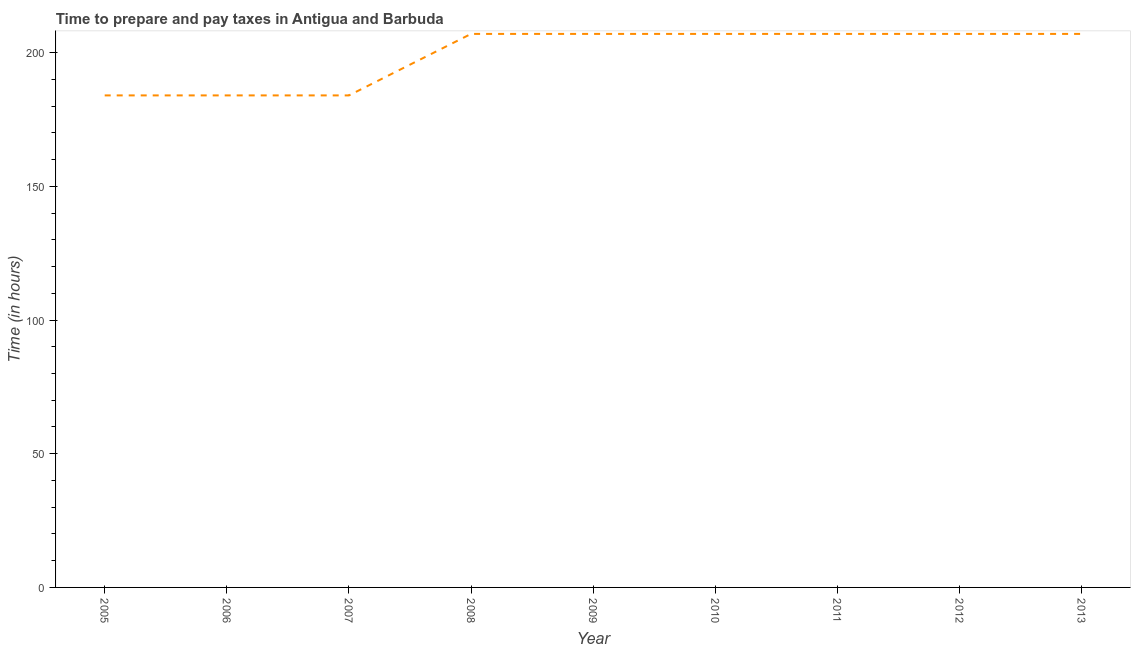What is the time to prepare and pay taxes in 2012?
Make the answer very short. 207. Across all years, what is the maximum time to prepare and pay taxes?
Keep it short and to the point. 207. Across all years, what is the minimum time to prepare and pay taxes?
Offer a very short reply. 184. In which year was the time to prepare and pay taxes maximum?
Ensure brevity in your answer.  2008. In which year was the time to prepare and pay taxes minimum?
Your response must be concise. 2005. What is the sum of the time to prepare and pay taxes?
Provide a short and direct response. 1794. What is the difference between the time to prepare and pay taxes in 2006 and 2013?
Offer a very short reply. -23. What is the average time to prepare and pay taxes per year?
Provide a succinct answer. 199.33. What is the median time to prepare and pay taxes?
Keep it short and to the point. 207. In how many years, is the time to prepare and pay taxes greater than 150 hours?
Make the answer very short. 9. What is the ratio of the time to prepare and pay taxes in 2010 to that in 2013?
Provide a succinct answer. 1. Is the difference between the time to prepare and pay taxes in 2006 and 2007 greater than the difference between any two years?
Make the answer very short. No. What is the difference between the highest and the second highest time to prepare and pay taxes?
Your answer should be compact. 0. What is the difference between the highest and the lowest time to prepare and pay taxes?
Your answer should be very brief. 23. What is the difference between two consecutive major ticks on the Y-axis?
Give a very brief answer. 50. Does the graph contain any zero values?
Offer a very short reply. No. What is the title of the graph?
Keep it short and to the point. Time to prepare and pay taxes in Antigua and Barbuda. What is the label or title of the Y-axis?
Ensure brevity in your answer.  Time (in hours). What is the Time (in hours) in 2005?
Your response must be concise. 184. What is the Time (in hours) of 2006?
Provide a short and direct response. 184. What is the Time (in hours) of 2007?
Provide a short and direct response. 184. What is the Time (in hours) of 2008?
Provide a succinct answer. 207. What is the Time (in hours) of 2009?
Offer a terse response. 207. What is the Time (in hours) in 2010?
Give a very brief answer. 207. What is the Time (in hours) of 2011?
Make the answer very short. 207. What is the Time (in hours) in 2012?
Your answer should be very brief. 207. What is the Time (in hours) of 2013?
Offer a very short reply. 207. What is the difference between the Time (in hours) in 2005 and 2006?
Ensure brevity in your answer.  0. What is the difference between the Time (in hours) in 2005 and 2010?
Give a very brief answer. -23. What is the difference between the Time (in hours) in 2005 and 2011?
Provide a short and direct response. -23. What is the difference between the Time (in hours) in 2005 and 2013?
Offer a very short reply. -23. What is the difference between the Time (in hours) in 2006 and 2008?
Keep it short and to the point. -23. What is the difference between the Time (in hours) in 2006 and 2010?
Keep it short and to the point. -23. What is the difference between the Time (in hours) in 2006 and 2011?
Offer a very short reply. -23. What is the difference between the Time (in hours) in 2006 and 2013?
Your answer should be very brief. -23. What is the difference between the Time (in hours) in 2007 and 2009?
Your answer should be very brief. -23. What is the difference between the Time (in hours) in 2007 and 2011?
Offer a very short reply. -23. What is the difference between the Time (in hours) in 2007 and 2012?
Your answer should be compact. -23. What is the difference between the Time (in hours) in 2008 and 2009?
Keep it short and to the point. 0. What is the difference between the Time (in hours) in 2008 and 2010?
Offer a very short reply. 0. What is the difference between the Time (in hours) in 2008 and 2013?
Your response must be concise. 0. What is the difference between the Time (in hours) in 2009 and 2010?
Provide a succinct answer. 0. What is the difference between the Time (in hours) in 2009 and 2011?
Ensure brevity in your answer.  0. What is the difference between the Time (in hours) in 2009 and 2012?
Give a very brief answer. 0. What is the difference between the Time (in hours) in 2010 and 2011?
Your response must be concise. 0. What is the difference between the Time (in hours) in 2011 and 2012?
Keep it short and to the point. 0. What is the difference between the Time (in hours) in 2012 and 2013?
Provide a succinct answer. 0. What is the ratio of the Time (in hours) in 2005 to that in 2006?
Ensure brevity in your answer.  1. What is the ratio of the Time (in hours) in 2005 to that in 2008?
Offer a terse response. 0.89. What is the ratio of the Time (in hours) in 2005 to that in 2009?
Give a very brief answer. 0.89. What is the ratio of the Time (in hours) in 2005 to that in 2010?
Your answer should be very brief. 0.89. What is the ratio of the Time (in hours) in 2005 to that in 2011?
Keep it short and to the point. 0.89. What is the ratio of the Time (in hours) in 2005 to that in 2012?
Offer a terse response. 0.89. What is the ratio of the Time (in hours) in 2005 to that in 2013?
Your answer should be compact. 0.89. What is the ratio of the Time (in hours) in 2006 to that in 2007?
Offer a terse response. 1. What is the ratio of the Time (in hours) in 2006 to that in 2008?
Your answer should be very brief. 0.89. What is the ratio of the Time (in hours) in 2006 to that in 2009?
Your answer should be very brief. 0.89. What is the ratio of the Time (in hours) in 2006 to that in 2010?
Provide a succinct answer. 0.89. What is the ratio of the Time (in hours) in 2006 to that in 2011?
Give a very brief answer. 0.89. What is the ratio of the Time (in hours) in 2006 to that in 2012?
Ensure brevity in your answer.  0.89. What is the ratio of the Time (in hours) in 2006 to that in 2013?
Make the answer very short. 0.89. What is the ratio of the Time (in hours) in 2007 to that in 2008?
Ensure brevity in your answer.  0.89. What is the ratio of the Time (in hours) in 2007 to that in 2009?
Offer a terse response. 0.89. What is the ratio of the Time (in hours) in 2007 to that in 2010?
Offer a terse response. 0.89. What is the ratio of the Time (in hours) in 2007 to that in 2011?
Provide a succinct answer. 0.89. What is the ratio of the Time (in hours) in 2007 to that in 2012?
Your response must be concise. 0.89. What is the ratio of the Time (in hours) in 2007 to that in 2013?
Your response must be concise. 0.89. What is the ratio of the Time (in hours) in 2008 to that in 2009?
Provide a succinct answer. 1. What is the ratio of the Time (in hours) in 2008 to that in 2010?
Offer a terse response. 1. What is the ratio of the Time (in hours) in 2009 to that in 2012?
Give a very brief answer. 1. What is the ratio of the Time (in hours) in 2010 to that in 2011?
Your response must be concise. 1. What is the ratio of the Time (in hours) in 2010 to that in 2012?
Offer a very short reply. 1. What is the ratio of the Time (in hours) in 2011 to that in 2013?
Offer a terse response. 1. What is the ratio of the Time (in hours) in 2012 to that in 2013?
Give a very brief answer. 1. 